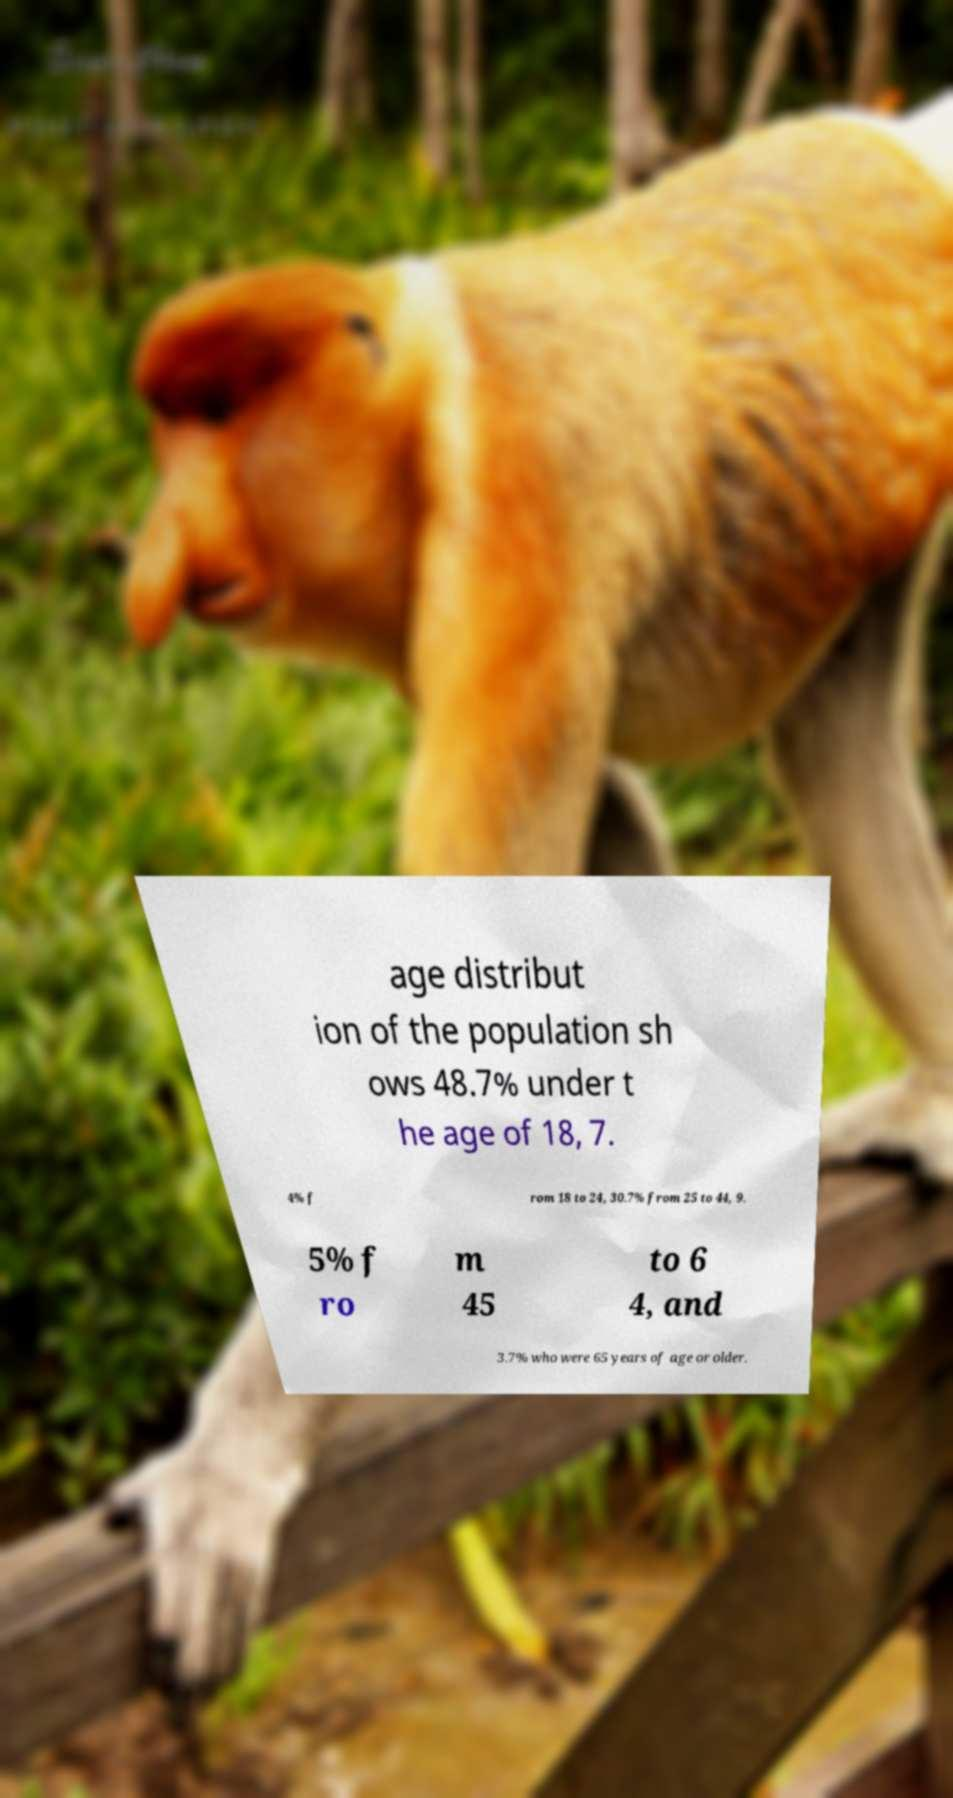What messages or text are displayed in this image? I need them in a readable, typed format. age distribut ion of the population sh ows 48.7% under t he age of 18, 7. 4% f rom 18 to 24, 30.7% from 25 to 44, 9. 5% f ro m 45 to 6 4, and 3.7% who were 65 years of age or older. 